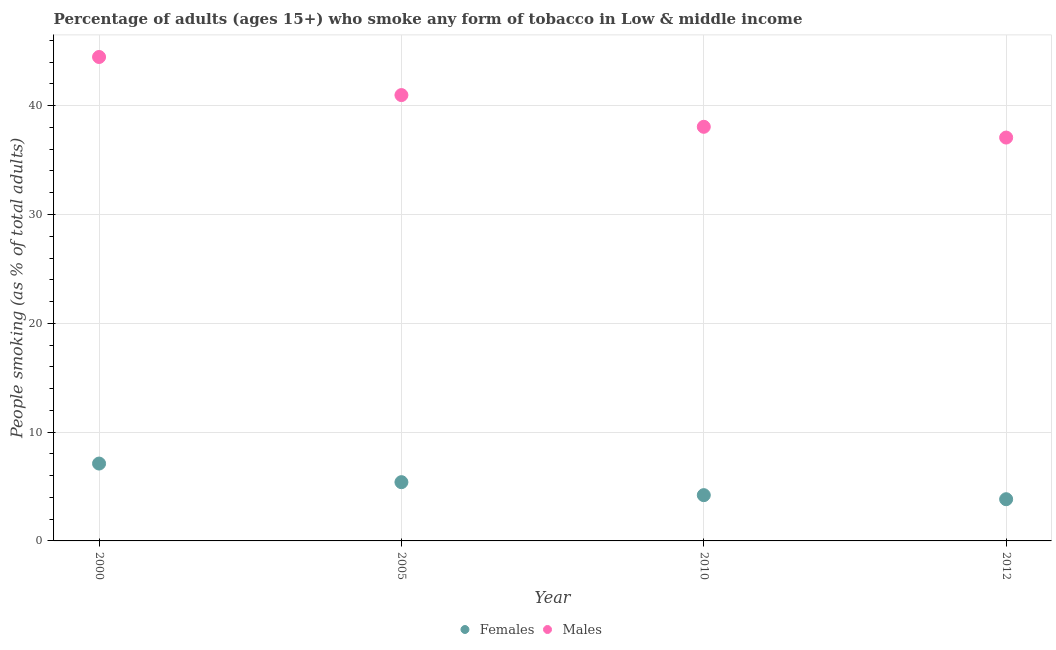Is the number of dotlines equal to the number of legend labels?
Give a very brief answer. Yes. What is the percentage of males who smoke in 2010?
Offer a very short reply. 38.06. Across all years, what is the maximum percentage of females who smoke?
Your answer should be very brief. 7.11. Across all years, what is the minimum percentage of females who smoke?
Ensure brevity in your answer.  3.83. In which year was the percentage of males who smoke minimum?
Your answer should be very brief. 2012. What is the total percentage of females who smoke in the graph?
Offer a terse response. 20.55. What is the difference between the percentage of males who smoke in 2010 and that in 2012?
Make the answer very short. 0.99. What is the difference between the percentage of females who smoke in 2010 and the percentage of males who smoke in 2000?
Provide a short and direct response. -40.27. What is the average percentage of females who smoke per year?
Offer a very short reply. 5.14. In the year 2000, what is the difference between the percentage of females who smoke and percentage of males who smoke?
Ensure brevity in your answer.  -37.37. In how many years, is the percentage of females who smoke greater than 14 %?
Offer a very short reply. 0. What is the ratio of the percentage of males who smoke in 2005 to that in 2010?
Offer a very short reply. 1.08. Is the percentage of males who smoke in 2000 less than that in 2010?
Make the answer very short. No. Is the difference between the percentage of males who smoke in 2005 and 2010 greater than the difference between the percentage of females who smoke in 2005 and 2010?
Offer a very short reply. Yes. What is the difference between the highest and the second highest percentage of females who smoke?
Give a very brief answer. 1.71. What is the difference between the highest and the lowest percentage of males who smoke?
Offer a very short reply. 7.41. Does the percentage of males who smoke monotonically increase over the years?
Provide a succinct answer. No. Is the percentage of females who smoke strictly greater than the percentage of males who smoke over the years?
Provide a short and direct response. No. How many dotlines are there?
Offer a terse response. 2. How many years are there in the graph?
Offer a very short reply. 4. Does the graph contain grids?
Keep it short and to the point. Yes. Where does the legend appear in the graph?
Give a very brief answer. Bottom center. How are the legend labels stacked?
Your answer should be compact. Horizontal. What is the title of the graph?
Provide a short and direct response. Percentage of adults (ages 15+) who smoke any form of tobacco in Low & middle income. What is the label or title of the Y-axis?
Your answer should be compact. People smoking (as % of total adults). What is the People smoking (as % of total adults) of Females in 2000?
Ensure brevity in your answer.  7.11. What is the People smoking (as % of total adults) in Males in 2000?
Make the answer very short. 44.48. What is the People smoking (as % of total adults) of Females in 2005?
Ensure brevity in your answer.  5.4. What is the People smoking (as % of total adults) of Males in 2005?
Offer a terse response. 40.98. What is the People smoking (as % of total adults) in Females in 2010?
Provide a succinct answer. 4.21. What is the People smoking (as % of total adults) in Males in 2010?
Give a very brief answer. 38.06. What is the People smoking (as % of total adults) in Females in 2012?
Make the answer very short. 3.83. What is the People smoking (as % of total adults) in Males in 2012?
Your answer should be compact. 37.07. Across all years, what is the maximum People smoking (as % of total adults) in Females?
Ensure brevity in your answer.  7.11. Across all years, what is the maximum People smoking (as % of total adults) in Males?
Offer a terse response. 44.48. Across all years, what is the minimum People smoking (as % of total adults) of Females?
Your answer should be very brief. 3.83. Across all years, what is the minimum People smoking (as % of total adults) of Males?
Make the answer very short. 37.07. What is the total People smoking (as % of total adults) of Females in the graph?
Give a very brief answer. 20.55. What is the total People smoking (as % of total adults) of Males in the graph?
Offer a terse response. 160.59. What is the difference between the People smoking (as % of total adults) in Females in 2000 and that in 2005?
Give a very brief answer. 1.71. What is the difference between the People smoking (as % of total adults) of Males in 2000 and that in 2005?
Provide a succinct answer. 3.5. What is the difference between the People smoking (as % of total adults) of Females in 2000 and that in 2010?
Ensure brevity in your answer.  2.9. What is the difference between the People smoking (as % of total adults) of Males in 2000 and that in 2010?
Ensure brevity in your answer.  6.42. What is the difference between the People smoking (as % of total adults) in Females in 2000 and that in 2012?
Provide a short and direct response. 3.28. What is the difference between the People smoking (as % of total adults) in Males in 2000 and that in 2012?
Give a very brief answer. 7.41. What is the difference between the People smoking (as % of total adults) in Females in 2005 and that in 2010?
Offer a terse response. 1.19. What is the difference between the People smoking (as % of total adults) in Males in 2005 and that in 2010?
Your answer should be very brief. 2.91. What is the difference between the People smoking (as % of total adults) in Females in 2005 and that in 2012?
Your response must be concise. 1.57. What is the difference between the People smoking (as % of total adults) of Males in 2005 and that in 2012?
Make the answer very short. 3.9. What is the difference between the People smoking (as % of total adults) in Females in 2010 and that in 2012?
Your answer should be very brief. 0.37. What is the difference between the People smoking (as % of total adults) in Males in 2010 and that in 2012?
Keep it short and to the point. 0.99. What is the difference between the People smoking (as % of total adults) in Females in 2000 and the People smoking (as % of total adults) in Males in 2005?
Offer a terse response. -33.87. What is the difference between the People smoking (as % of total adults) of Females in 2000 and the People smoking (as % of total adults) of Males in 2010?
Your answer should be compact. -30.95. What is the difference between the People smoking (as % of total adults) of Females in 2000 and the People smoking (as % of total adults) of Males in 2012?
Ensure brevity in your answer.  -29.96. What is the difference between the People smoking (as % of total adults) in Females in 2005 and the People smoking (as % of total adults) in Males in 2010?
Your response must be concise. -32.66. What is the difference between the People smoking (as % of total adults) in Females in 2005 and the People smoking (as % of total adults) in Males in 2012?
Give a very brief answer. -31.67. What is the difference between the People smoking (as % of total adults) in Females in 2010 and the People smoking (as % of total adults) in Males in 2012?
Give a very brief answer. -32.87. What is the average People smoking (as % of total adults) in Females per year?
Provide a succinct answer. 5.14. What is the average People smoking (as % of total adults) in Males per year?
Your response must be concise. 40.15. In the year 2000, what is the difference between the People smoking (as % of total adults) in Females and People smoking (as % of total adults) in Males?
Provide a succinct answer. -37.37. In the year 2005, what is the difference between the People smoking (as % of total adults) in Females and People smoking (as % of total adults) in Males?
Your answer should be compact. -35.58. In the year 2010, what is the difference between the People smoking (as % of total adults) of Females and People smoking (as % of total adults) of Males?
Make the answer very short. -33.86. In the year 2012, what is the difference between the People smoking (as % of total adults) of Females and People smoking (as % of total adults) of Males?
Your answer should be very brief. -33.24. What is the ratio of the People smoking (as % of total adults) of Females in 2000 to that in 2005?
Give a very brief answer. 1.32. What is the ratio of the People smoking (as % of total adults) of Males in 2000 to that in 2005?
Keep it short and to the point. 1.09. What is the ratio of the People smoking (as % of total adults) of Females in 2000 to that in 2010?
Offer a very short reply. 1.69. What is the ratio of the People smoking (as % of total adults) of Males in 2000 to that in 2010?
Give a very brief answer. 1.17. What is the ratio of the People smoking (as % of total adults) in Females in 2000 to that in 2012?
Give a very brief answer. 1.85. What is the ratio of the People smoking (as % of total adults) of Males in 2000 to that in 2012?
Provide a short and direct response. 1.2. What is the ratio of the People smoking (as % of total adults) in Females in 2005 to that in 2010?
Provide a succinct answer. 1.28. What is the ratio of the People smoking (as % of total adults) in Males in 2005 to that in 2010?
Give a very brief answer. 1.08. What is the ratio of the People smoking (as % of total adults) in Females in 2005 to that in 2012?
Your answer should be compact. 1.41. What is the ratio of the People smoking (as % of total adults) in Males in 2005 to that in 2012?
Give a very brief answer. 1.11. What is the ratio of the People smoking (as % of total adults) of Females in 2010 to that in 2012?
Your response must be concise. 1.1. What is the ratio of the People smoking (as % of total adults) in Males in 2010 to that in 2012?
Your answer should be compact. 1.03. What is the difference between the highest and the second highest People smoking (as % of total adults) of Females?
Offer a terse response. 1.71. What is the difference between the highest and the second highest People smoking (as % of total adults) of Males?
Ensure brevity in your answer.  3.5. What is the difference between the highest and the lowest People smoking (as % of total adults) of Females?
Offer a very short reply. 3.28. What is the difference between the highest and the lowest People smoking (as % of total adults) in Males?
Make the answer very short. 7.41. 